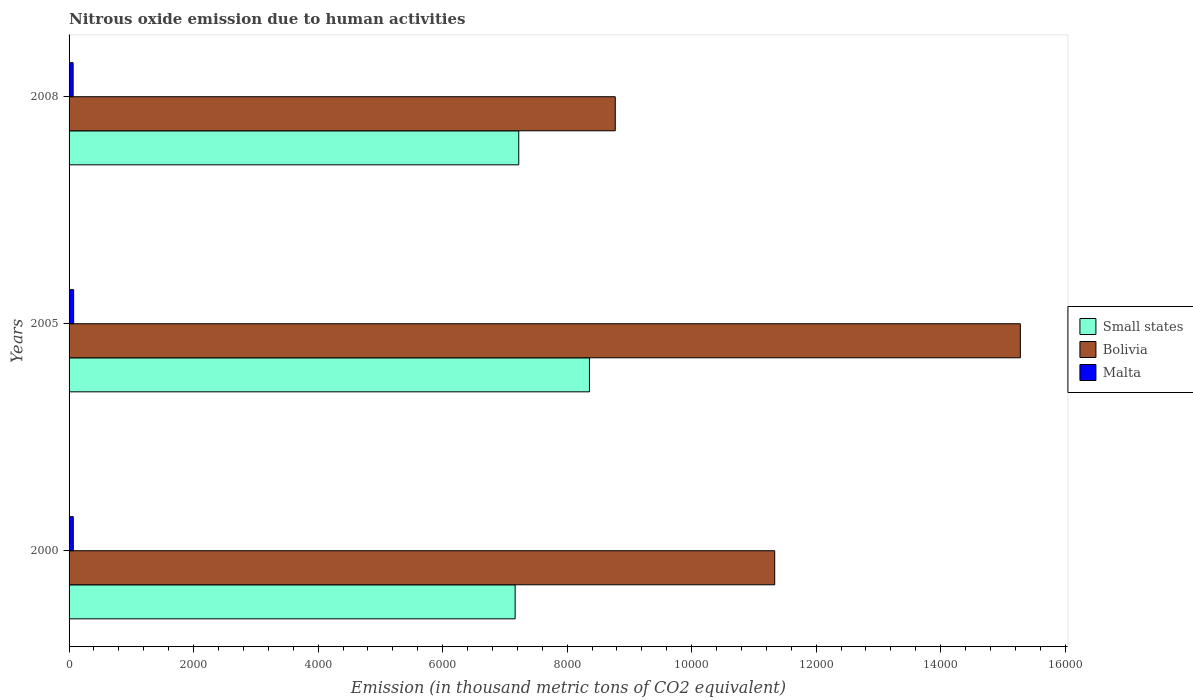How many groups of bars are there?
Your answer should be compact. 3. Are the number of bars on each tick of the Y-axis equal?
Your response must be concise. Yes. In how many cases, is the number of bars for a given year not equal to the number of legend labels?
Your answer should be compact. 0. What is the amount of nitrous oxide emitted in Bolivia in 2005?
Make the answer very short. 1.53e+04. Across all years, what is the maximum amount of nitrous oxide emitted in Malta?
Make the answer very short. 73.3. Across all years, what is the minimum amount of nitrous oxide emitted in Bolivia?
Your response must be concise. 8773. In which year was the amount of nitrous oxide emitted in Malta minimum?
Offer a terse response. 2008. What is the total amount of nitrous oxide emitted in Malta in the graph?
Make the answer very short. 206.1. What is the difference between the amount of nitrous oxide emitted in Malta in 2000 and that in 2005?
Your answer should be compact. -5.6. What is the difference between the amount of nitrous oxide emitted in Bolivia in 2005 and the amount of nitrous oxide emitted in Small states in 2000?
Make the answer very short. 8114.8. What is the average amount of nitrous oxide emitted in Malta per year?
Your answer should be compact. 68.7. In the year 2000, what is the difference between the amount of nitrous oxide emitted in Small states and amount of nitrous oxide emitted in Bolivia?
Ensure brevity in your answer.  -4169.4. In how many years, is the amount of nitrous oxide emitted in Small states greater than 7200 thousand metric tons?
Your answer should be very brief. 2. What is the ratio of the amount of nitrous oxide emitted in Bolivia in 2000 to that in 2008?
Give a very brief answer. 1.29. What is the difference between the highest and the second highest amount of nitrous oxide emitted in Small states?
Ensure brevity in your answer.  1135.4. What is the difference between the highest and the lowest amount of nitrous oxide emitted in Bolivia?
Give a very brief answer. 6506.5. Is the sum of the amount of nitrous oxide emitted in Bolivia in 2000 and 2005 greater than the maximum amount of nitrous oxide emitted in Malta across all years?
Offer a very short reply. Yes. What does the 1st bar from the top in 2005 represents?
Give a very brief answer. Malta. What does the 3rd bar from the bottom in 2000 represents?
Make the answer very short. Malta. Is it the case that in every year, the sum of the amount of nitrous oxide emitted in Small states and amount of nitrous oxide emitted in Bolivia is greater than the amount of nitrous oxide emitted in Malta?
Your answer should be compact. Yes. Are all the bars in the graph horizontal?
Ensure brevity in your answer.  Yes. Does the graph contain grids?
Your answer should be compact. No. How many legend labels are there?
Provide a succinct answer. 3. What is the title of the graph?
Your answer should be very brief. Nitrous oxide emission due to human activities. What is the label or title of the X-axis?
Your response must be concise. Emission (in thousand metric tons of CO2 equivalent). What is the Emission (in thousand metric tons of CO2 equivalent) in Small states in 2000?
Provide a succinct answer. 7164.7. What is the Emission (in thousand metric tons of CO2 equivalent) in Bolivia in 2000?
Keep it short and to the point. 1.13e+04. What is the Emission (in thousand metric tons of CO2 equivalent) in Malta in 2000?
Keep it short and to the point. 67.7. What is the Emission (in thousand metric tons of CO2 equivalent) of Small states in 2005?
Your answer should be very brief. 8358.1. What is the Emission (in thousand metric tons of CO2 equivalent) in Bolivia in 2005?
Ensure brevity in your answer.  1.53e+04. What is the Emission (in thousand metric tons of CO2 equivalent) of Malta in 2005?
Provide a succinct answer. 73.3. What is the Emission (in thousand metric tons of CO2 equivalent) in Small states in 2008?
Give a very brief answer. 7222.7. What is the Emission (in thousand metric tons of CO2 equivalent) of Bolivia in 2008?
Ensure brevity in your answer.  8773. What is the Emission (in thousand metric tons of CO2 equivalent) of Malta in 2008?
Ensure brevity in your answer.  65.1. Across all years, what is the maximum Emission (in thousand metric tons of CO2 equivalent) of Small states?
Your answer should be very brief. 8358.1. Across all years, what is the maximum Emission (in thousand metric tons of CO2 equivalent) in Bolivia?
Offer a terse response. 1.53e+04. Across all years, what is the maximum Emission (in thousand metric tons of CO2 equivalent) of Malta?
Keep it short and to the point. 73.3. Across all years, what is the minimum Emission (in thousand metric tons of CO2 equivalent) in Small states?
Offer a terse response. 7164.7. Across all years, what is the minimum Emission (in thousand metric tons of CO2 equivalent) in Bolivia?
Your answer should be compact. 8773. Across all years, what is the minimum Emission (in thousand metric tons of CO2 equivalent) in Malta?
Provide a succinct answer. 65.1. What is the total Emission (in thousand metric tons of CO2 equivalent) of Small states in the graph?
Give a very brief answer. 2.27e+04. What is the total Emission (in thousand metric tons of CO2 equivalent) of Bolivia in the graph?
Your answer should be compact. 3.54e+04. What is the total Emission (in thousand metric tons of CO2 equivalent) in Malta in the graph?
Provide a succinct answer. 206.1. What is the difference between the Emission (in thousand metric tons of CO2 equivalent) in Small states in 2000 and that in 2005?
Provide a succinct answer. -1193.4. What is the difference between the Emission (in thousand metric tons of CO2 equivalent) in Bolivia in 2000 and that in 2005?
Keep it short and to the point. -3945.4. What is the difference between the Emission (in thousand metric tons of CO2 equivalent) in Small states in 2000 and that in 2008?
Provide a succinct answer. -58. What is the difference between the Emission (in thousand metric tons of CO2 equivalent) of Bolivia in 2000 and that in 2008?
Provide a short and direct response. 2561.1. What is the difference between the Emission (in thousand metric tons of CO2 equivalent) of Malta in 2000 and that in 2008?
Provide a short and direct response. 2.6. What is the difference between the Emission (in thousand metric tons of CO2 equivalent) of Small states in 2005 and that in 2008?
Provide a short and direct response. 1135.4. What is the difference between the Emission (in thousand metric tons of CO2 equivalent) of Bolivia in 2005 and that in 2008?
Your response must be concise. 6506.5. What is the difference between the Emission (in thousand metric tons of CO2 equivalent) of Malta in 2005 and that in 2008?
Provide a succinct answer. 8.2. What is the difference between the Emission (in thousand metric tons of CO2 equivalent) of Small states in 2000 and the Emission (in thousand metric tons of CO2 equivalent) of Bolivia in 2005?
Give a very brief answer. -8114.8. What is the difference between the Emission (in thousand metric tons of CO2 equivalent) of Small states in 2000 and the Emission (in thousand metric tons of CO2 equivalent) of Malta in 2005?
Provide a short and direct response. 7091.4. What is the difference between the Emission (in thousand metric tons of CO2 equivalent) of Bolivia in 2000 and the Emission (in thousand metric tons of CO2 equivalent) of Malta in 2005?
Give a very brief answer. 1.13e+04. What is the difference between the Emission (in thousand metric tons of CO2 equivalent) of Small states in 2000 and the Emission (in thousand metric tons of CO2 equivalent) of Bolivia in 2008?
Offer a terse response. -1608.3. What is the difference between the Emission (in thousand metric tons of CO2 equivalent) of Small states in 2000 and the Emission (in thousand metric tons of CO2 equivalent) of Malta in 2008?
Your answer should be compact. 7099.6. What is the difference between the Emission (in thousand metric tons of CO2 equivalent) in Bolivia in 2000 and the Emission (in thousand metric tons of CO2 equivalent) in Malta in 2008?
Provide a succinct answer. 1.13e+04. What is the difference between the Emission (in thousand metric tons of CO2 equivalent) of Small states in 2005 and the Emission (in thousand metric tons of CO2 equivalent) of Bolivia in 2008?
Provide a short and direct response. -414.9. What is the difference between the Emission (in thousand metric tons of CO2 equivalent) in Small states in 2005 and the Emission (in thousand metric tons of CO2 equivalent) in Malta in 2008?
Your response must be concise. 8293. What is the difference between the Emission (in thousand metric tons of CO2 equivalent) in Bolivia in 2005 and the Emission (in thousand metric tons of CO2 equivalent) in Malta in 2008?
Your answer should be very brief. 1.52e+04. What is the average Emission (in thousand metric tons of CO2 equivalent) of Small states per year?
Keep it short and to the point. 7581.83. What is the average Emission (in thousand metric tons of CO2 equivalent) of Bolivia per year?
Provide a succinct answer. 1.18e+04. What is the average Emission (in thousand metric tons of CO2 equivalent) of Malta per year?
Give a very brief answer. 68.7. In the year 2000, what is the difference between the Emission (in thousand metric tons of CO2 equivalent) of Small states and Emission (in thousand metric tons of CO2 equivalent) of Bolivia?
Your answer should be very brief. -4169.4. In the year 2000, what is the difference between the Emission (in thousand metric tons of CO2 equivalent) in Small states and Emission (in thousand metric tons of CO2 equivalent) in Malta?
Give a very brief answer. 7097. In the year 2000, what is the difference between the Emission (in thousand metric tons of CO2 equivalent) in Bolivia and Emission (in thousand metric tons of CO2 equivalent) in Malta?
Give a very brief answer. 1.13e+04. In the year 2005, what is the difference between the Emission (in thousand metric tons of CO2 equivalent) of Small states and Emission (in thousand metric tons of CO2 equivalent) of Bolivia?
Offer a terse response. -6921.4. In the year 2005, what is the difference between the Emission (in thousand metric tons of CO2 equivalent) of Small states and Emission (in thousand metric tons of CO2 equivalent) of Malta?
Make the answer very short. 8284.8. In the year 2005, what is the difference between the Emission (in thousand metric tons of CO2 equivalent) in Bolivia and Emission (in thousand metric tons of CO2 equivalent) in Malta?
Your answer should be very brief. 1.52e+04. In the year 2008, what is the difference between the Emission (in thousand metric tons of CO2 equivalent) in Small states and Emission (in thousand metric tons of CO2 equivalent) in Bolivia?
Your answer should be very brief. -1550.3. In the year 2008, what is the difference between the Emission (in thousand metric tons of CO2 equivalent) in Small states and Emission (in thousand metric tons of CO2 equivalent) in Malta?
Ensure brevity in your answer.  7157.6. In the year 2008, what is the difference between the Emission (in thousand metric tons of CO2 equivalent) of Bolivia and Emission (in thousand metric tons of CO2 equivalent) of Malta?
Give a very brief answer. 8707.9. What is the ratio of the Emission (in thousand metric tons of CO2 equivalent) in Small states in 2000 to that in 2005?
Offer a very short reply. 0.86. What is the ratio of the Emission (in thousand metric tons of CO2 equivalent) in Bolivia in 2000 to that in 2005?
Ensure brevity in your answer.  0.74. What is the ratio of the Emission (in thousand metric tons of CO2 equivalent) of Malta in 2000 to that in 2005?
Ensure brevity in your answer.  0.92. What is the ratio of the Emission (in thousand metric tons of CO2 equivalent) of Bolivia in 2000 to that in 2008?
Your answer should be very brief. 1.29. What is the ratio of the Emission (in thousand metric tons of CO2 equivalent) in Malta in 2000 to that in 2008?
Your answer should be very brief. 1.04. What is the ratio of the Emission (in thousand metric tons of CO2 equivalent) in Small states in 2005 to that in 2008?
Your answer should be compact. 1.16. What is the ratio of the Emission (in thousand metric tons of CO2 equivalent) in Bolivia in 2005 to that in 2008?
Give a very brief answer. 1.74. What is the ratio of the Emission (in thousand metric tons of CO2 equivalent) in Malta in 2005 to that in 2008?
Give a very brief answer. 1.13. What is the difference between the highest and the second highest Emission (in thousand metric tons of CO2 equivalent) of Small states?
Offer a very short reply. 1135.4. What is the difference between the highest and the second highest Emission (in thousand metric tons of CO2 equivalent) of Bolivia?
Make the answer very short. 3945.4. What is the difference between the highest and the second highest Emission (in thousand metric tons of CO2 equivalent) in Malta?
Ensure brevity in your answer.  5.6. What is the difference between the highest and the lowest Emission (in thousand metric tons of CO2 equivalent) of Small states?
Ensure brevity in your answer.  1193.4. What is the difference between the highest and the lowest Emission (in thousand metric tons of CO2 equivalent) in Bolivia?
Provide a succinct answer. 6506.5. 